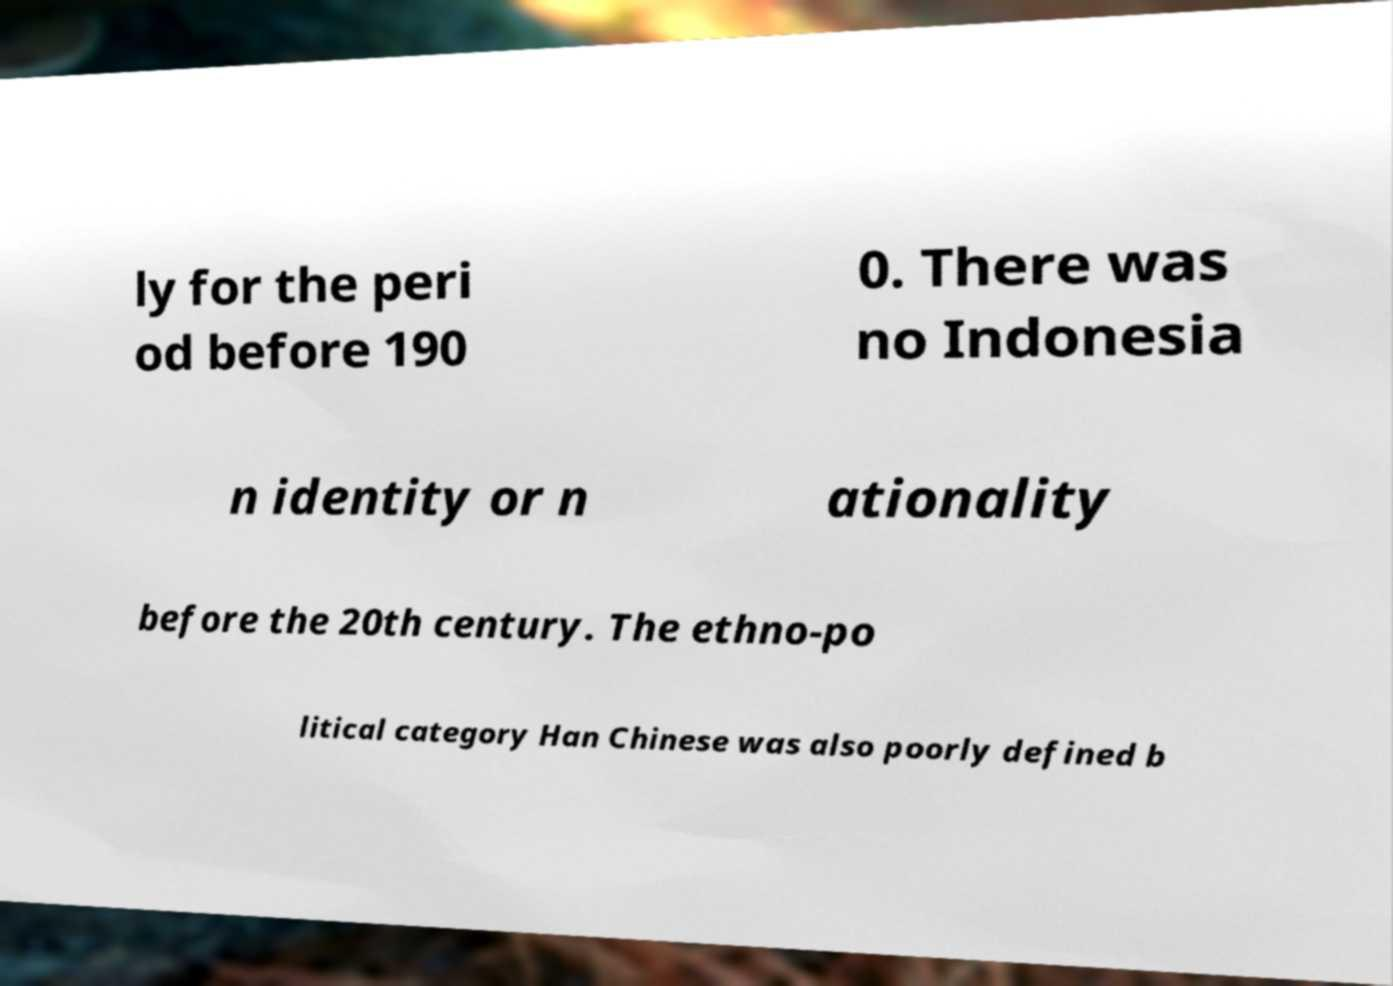There's text embedded in this image that I need extracted. Can you transcribe it verbatim? ly for the peri od before 190 0. There was no Indonesia n identity or n ationality before the 20th century. The ethno-po litical category Han Chinese was also poorly defined b 